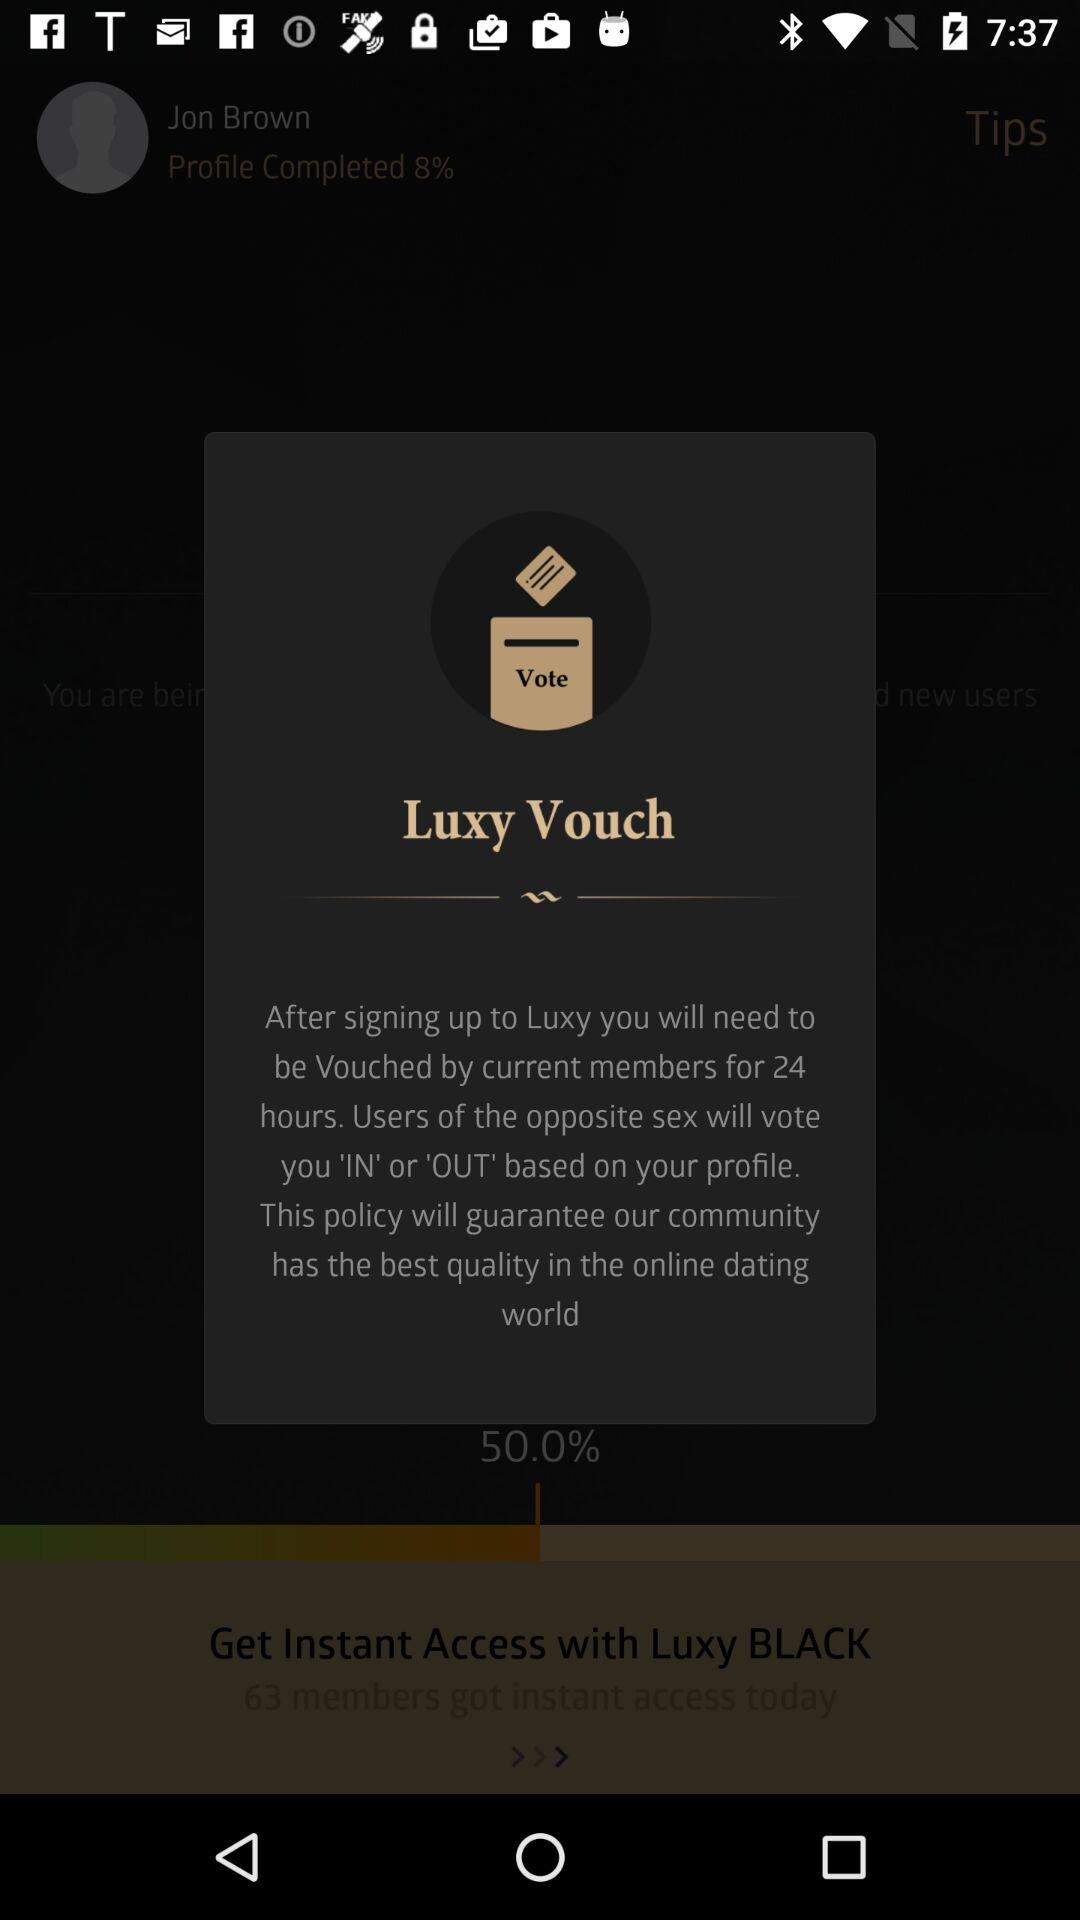What is the name of the application? The name of the application is "Luxy". 